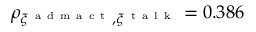<formula> <loc_0><loc_0><loc_500><loc_500>\rho _ { \xi ^ { a d m a c t } , \xi ^ { t a l k } } = 0 . 3 8 6</formula> 